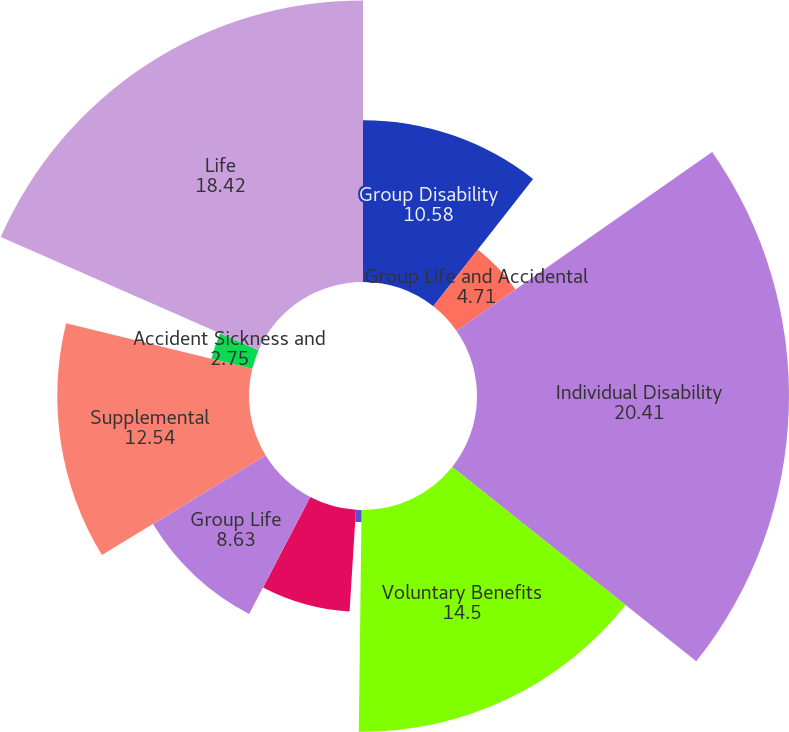Convert chart. <chart><loc_0><loc_0><loc_500><loc_500><pie_chart><fcel>Group Disability<fcel>Group Life and Accidental<fcel>Individual Disability<fcel>Voluntary Benefits<fcel>Dental and Vision<fcel>Group Long-term Disability<fcel>Group Life<fcel>Supplemental<fcel>Accident Sickness and<fcel>Life<nl><fcel>10.58%<fcel>4.71%<fcel>20.41%<fcel>14.5%<fcel>0.79%<fcel>6.67%<fcel>8.63%<fcel>12.54%<fcel>2.75%<fcel>18.42%<nl></chart> 